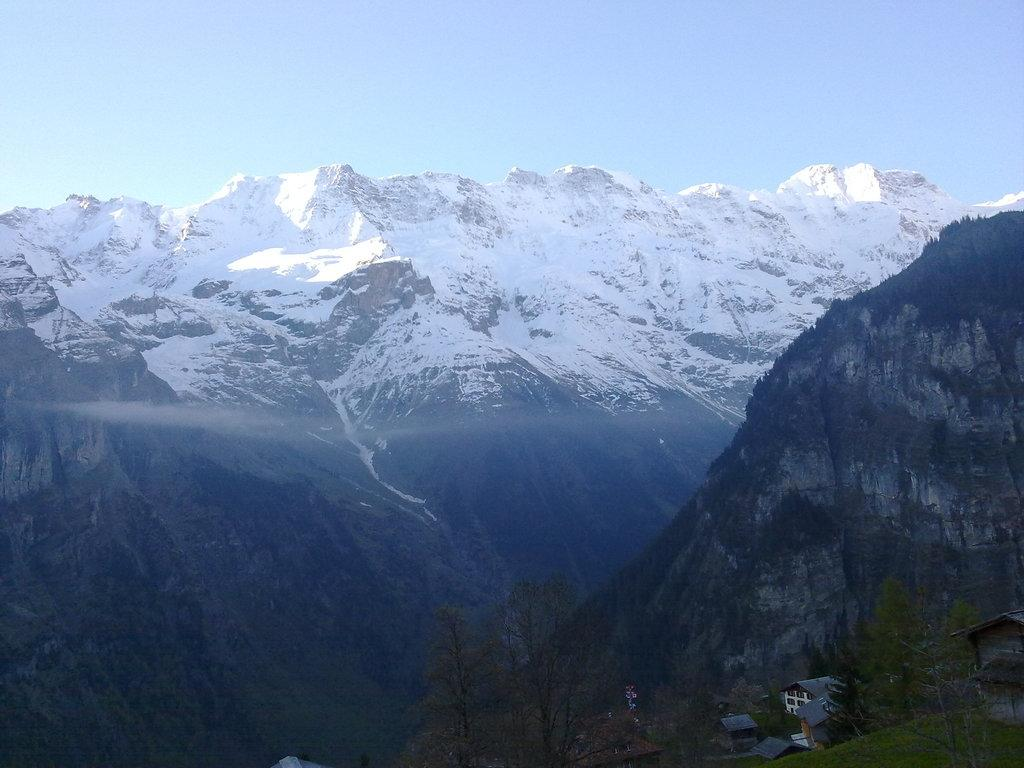What is the condition of the mountains in the image? The mountains in the image are covered with snow. What is visible at the top of the image? The sky is visible at the top of the image. What type of vegetation can be seen at the bottom of the image? Trees are present at the bottom of the image. What type of structures are visible at the bottom of the image? Houses are visible at the bottom of the image. What other objects can be seen at the bottom of the image? Other objects are present at the bottom of the image. What type of disease is affecting the trees at the bottom of the image? There is no indication of any disease affecting the trees in the image; they appear to be healthy. What type of crate is visible at the bottom of the image? There is no crate present in the image. What type of vegetable is growing at the bottom of the image? There is no vegetable growing in the image; only trees and other objects are present. 